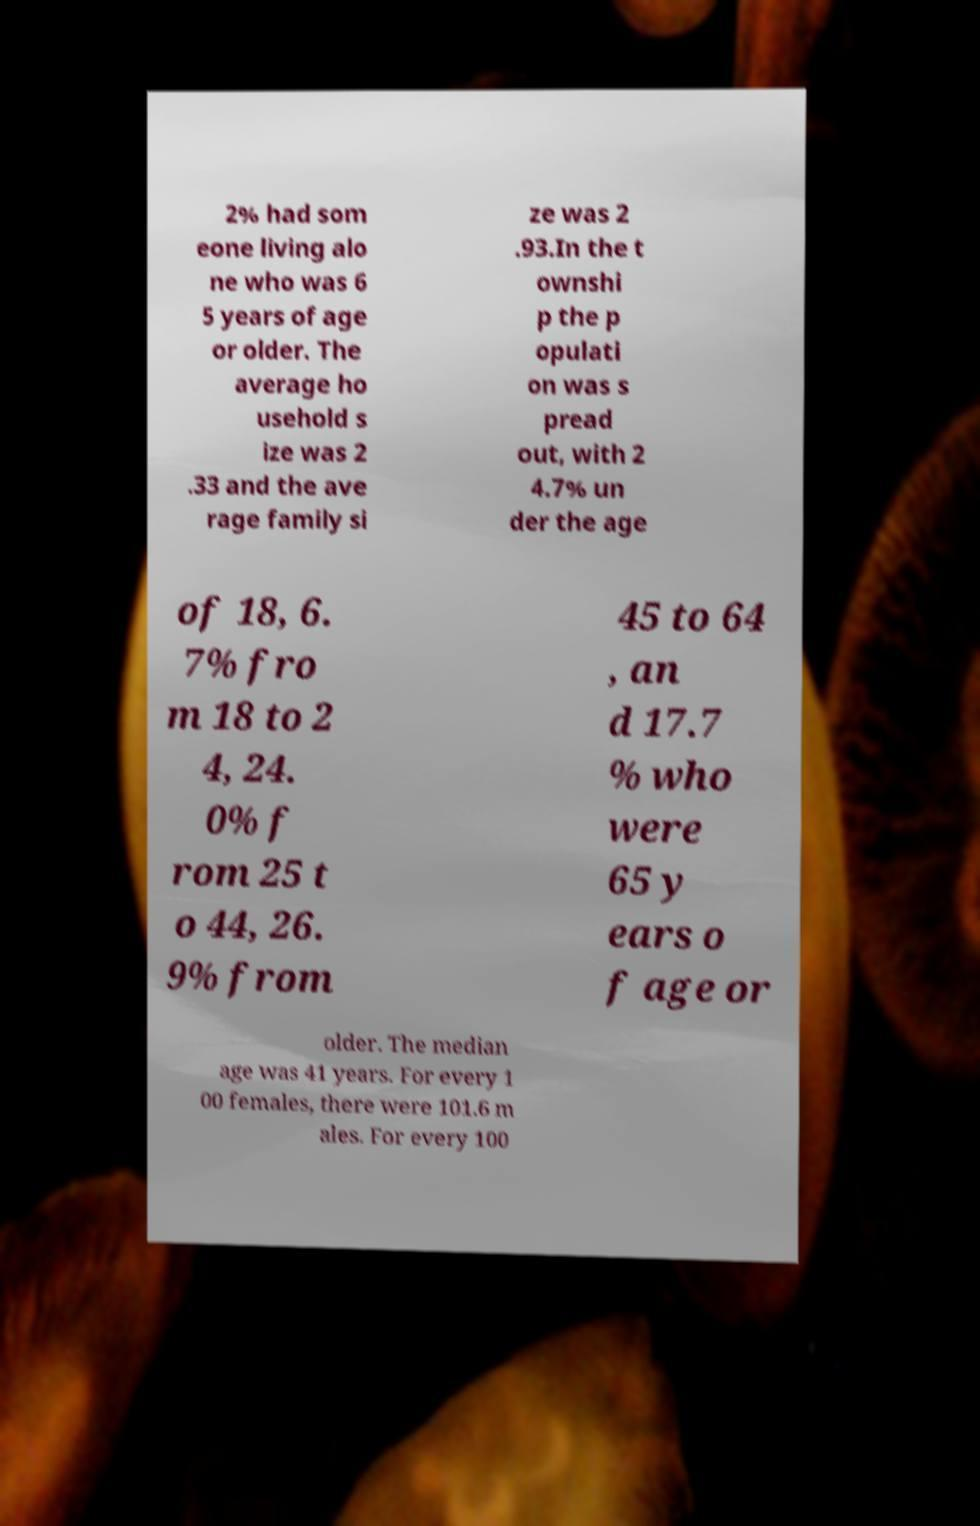Could you extract and type out the text from this image? 2% had som eone living alo ne who was 6 5 years of age or older. The average ho usehold s ize was 2 .33 and the ave rage family si ze was 2 .93.In the t ownshi p the p opulati on was s pread out, with 2 4.7% un der the age of 18, 6. 7% fro m 18 to 2 4, 24. 0% f rom 25 t o 44, 26. 9% from 45 to 64 , an d 17.7 % who were 65 y ears o f age or older. The median age was 41 years. For every 1 00 females, there were 101.6 m ales. For every 100 